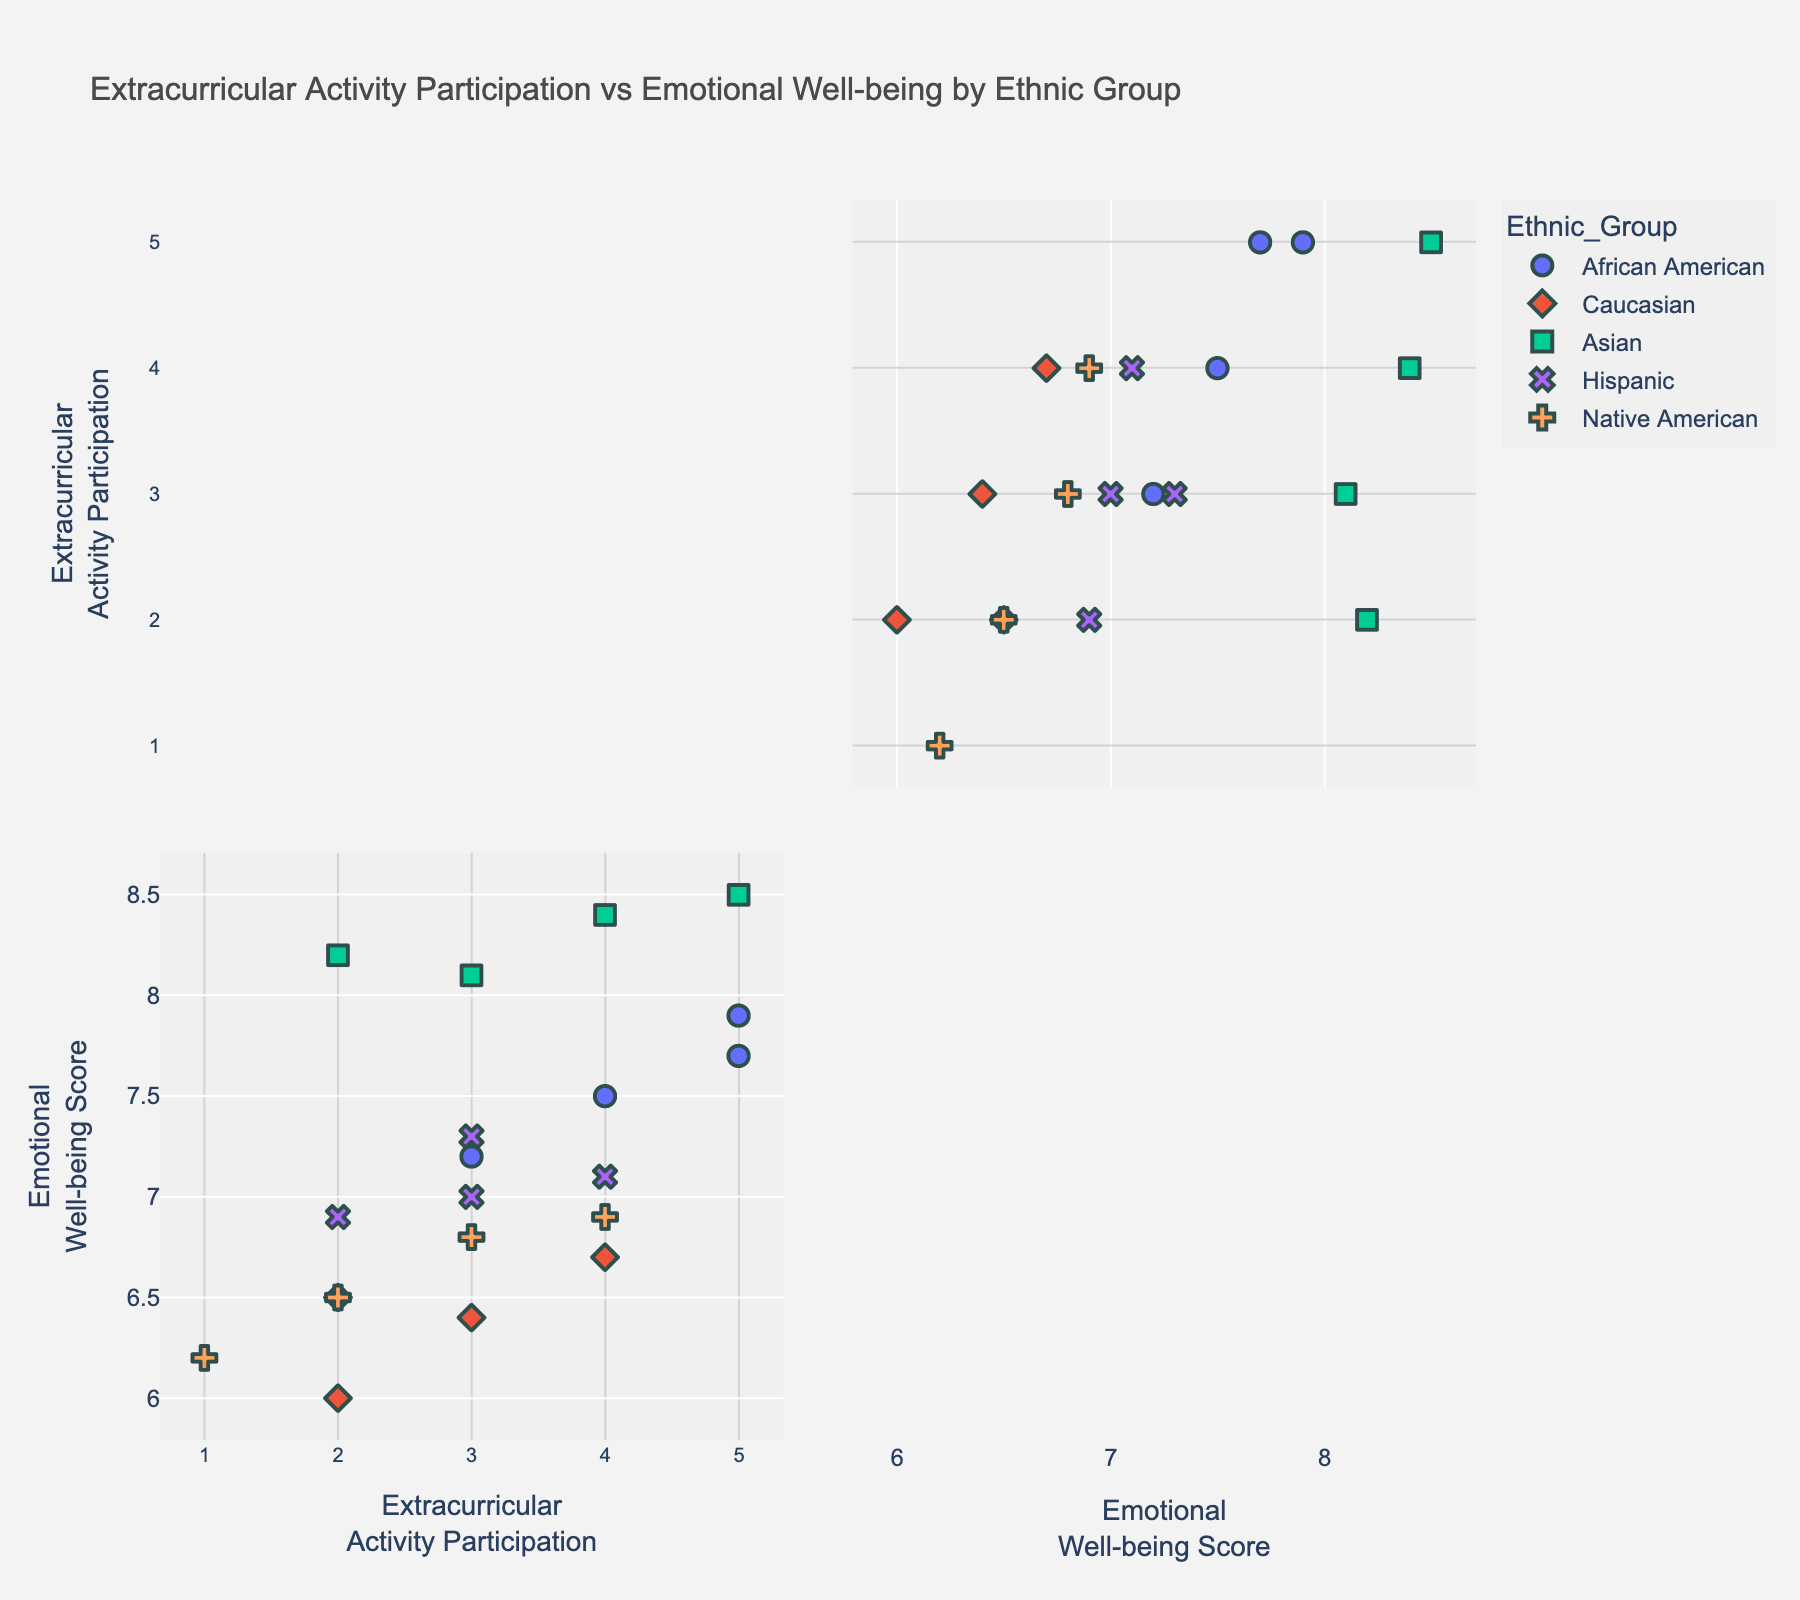What is the range of the Emotional Well-being Scores across all ethnic groups? To find the range, identify the minimum and maximum Emotional Well-being Scores in the figure. The minimum score appears to be 6.0 and the maximum appears to be 8.5. The range is the difference between these two values.
Answer: 2.5 Which ethnic group seems to have the highest Emotional Well-being Score on average? Identify the scores for each ethnic group and calculate the average. Asian students appear to have higher individual scores ranging around 8.0 - 8.5 compared to other groups.
Answer: Asian Do African American students participate more in extracurricular activities than Caucasian students? Compare the Extracurricular Participation axis values for African American and Caucasian students. African American students seem to have generally higher Extracurricular Participation values.
Answer: Yes Among all groups, which ethnic group has the maximum data points plotted? Count the number of data points for each ethnic group in the scatter plot. Caucasian students have the most data points.
Answer: Caucasian Is there a visible trend between Extracurricular Activity Participation and Emotional Well-being Score? Look for a pattern or correlation between the Extracurricular Activity Participation and Emotional Well-being Score. A positive correlation between participation and well-being scores is indicated by the upward trend in the scatter plots for each ethnic group.
Answer: Yes, positive trend For Hispanic students, what is the difference between their highest and lowest Emotional Well-being Scores? Identify the highest and lowest Emotional Well-being Scores for Hispanic students. The range goes from approximately 6.9 to 7.3. Calculate the difference.
Answer: 0.4 Are there any ethnic groups with overlapping data points in terms of Emotional Well-being Score and Extracurricular Activity Participation? Examine the scatter plots to see if the data points for different ethnic groups overlap on both the axes. Both Hispanic and Caucasian students overlap around the range of 2-4 in Extracurricular Participation and 6.4-7.3 in Emotional Well-being.
Answer: Yes Which ethnic group has the lowest data points in terms of Extracurricular Activity Participation? Check the Extracurricular Activity Participation axis for the lowest data points for each ethnic group. Native American students have some of the lowest Extracurricular Participation values.
Answer: Native American What is the median Extracurricular Activity Participation score for Caucasian students? Identify the Extracurricular Activity Participation values for Caucasian students and find the median value. The data points are 3, 2, 2, 4. The median is (2+3)/2.
Answer: 2.5 